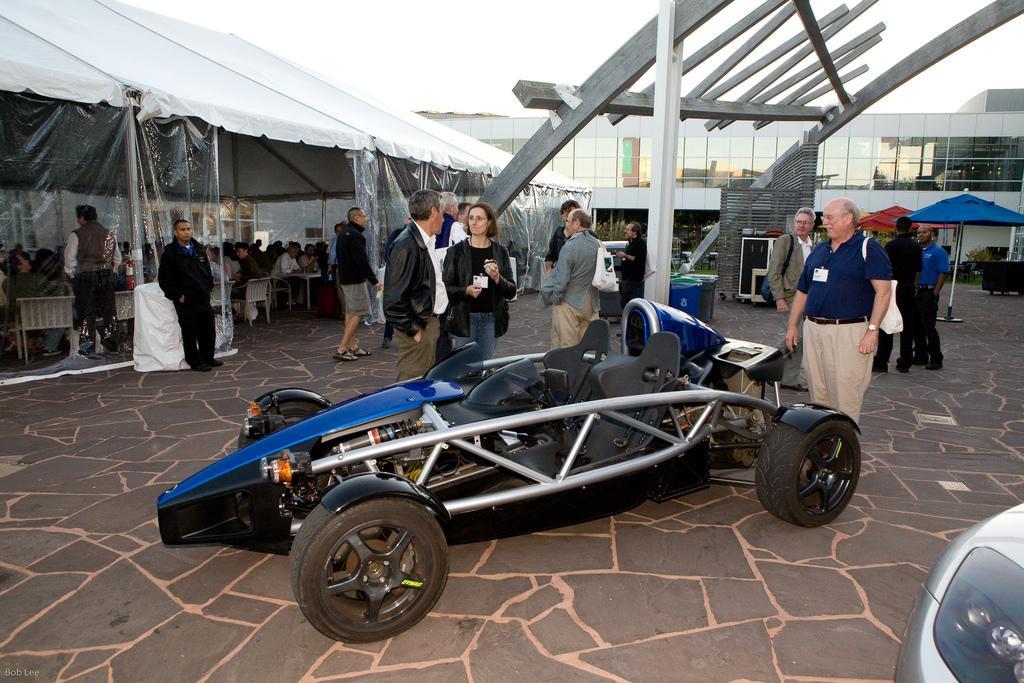Can you describe this image briefly? This is a vehicle and there are few persons. Here we can see a tent, bins, plants, an umbrella, and few persons are sitting on the chairs. In the background we can see a building and sky. 